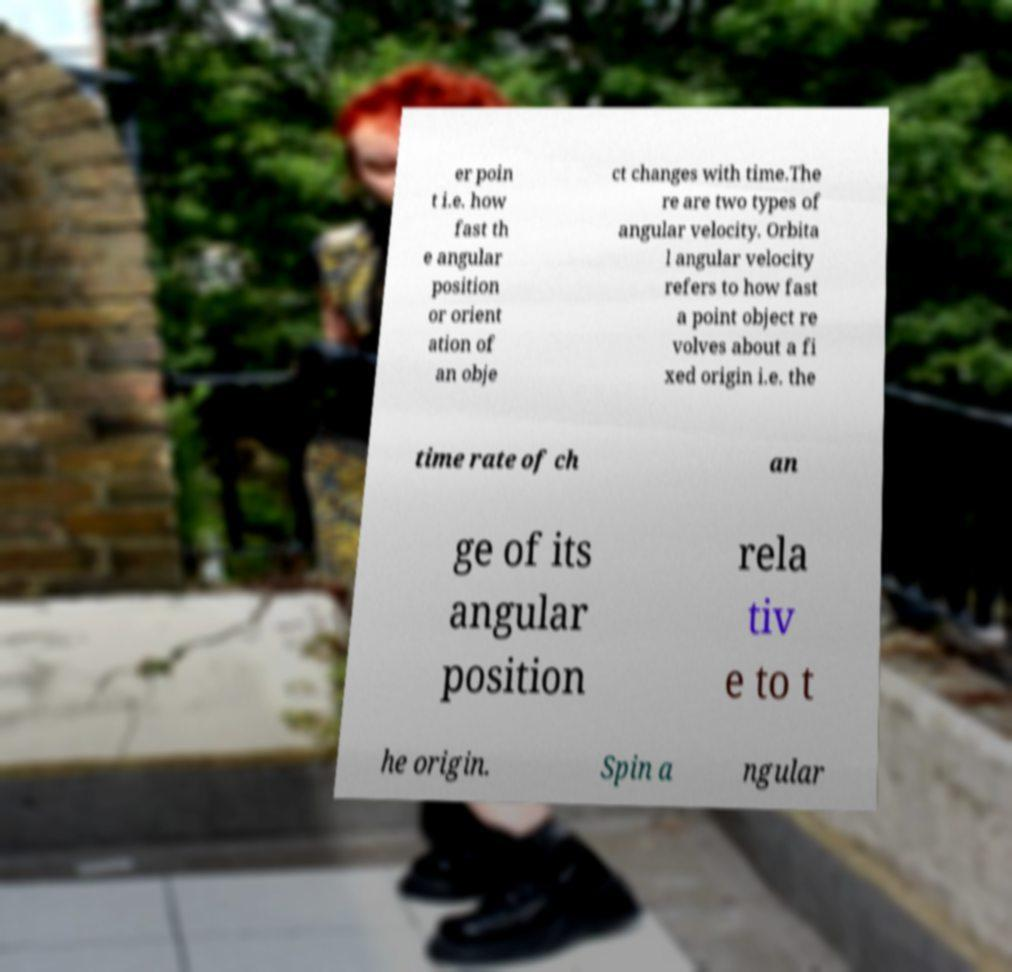Please identify and transcribe the text found in this image. er poin t i.e. how fast th e angular position or orient ation of an obje ct changes with time.The re are two types of angular velocity. Orbita l angular velocity refers to how fast a point object re volves about a fi xed origin i.e. the time rate of ch an ge of its angular position rela tiv e to t he origin. Spin a ngular 